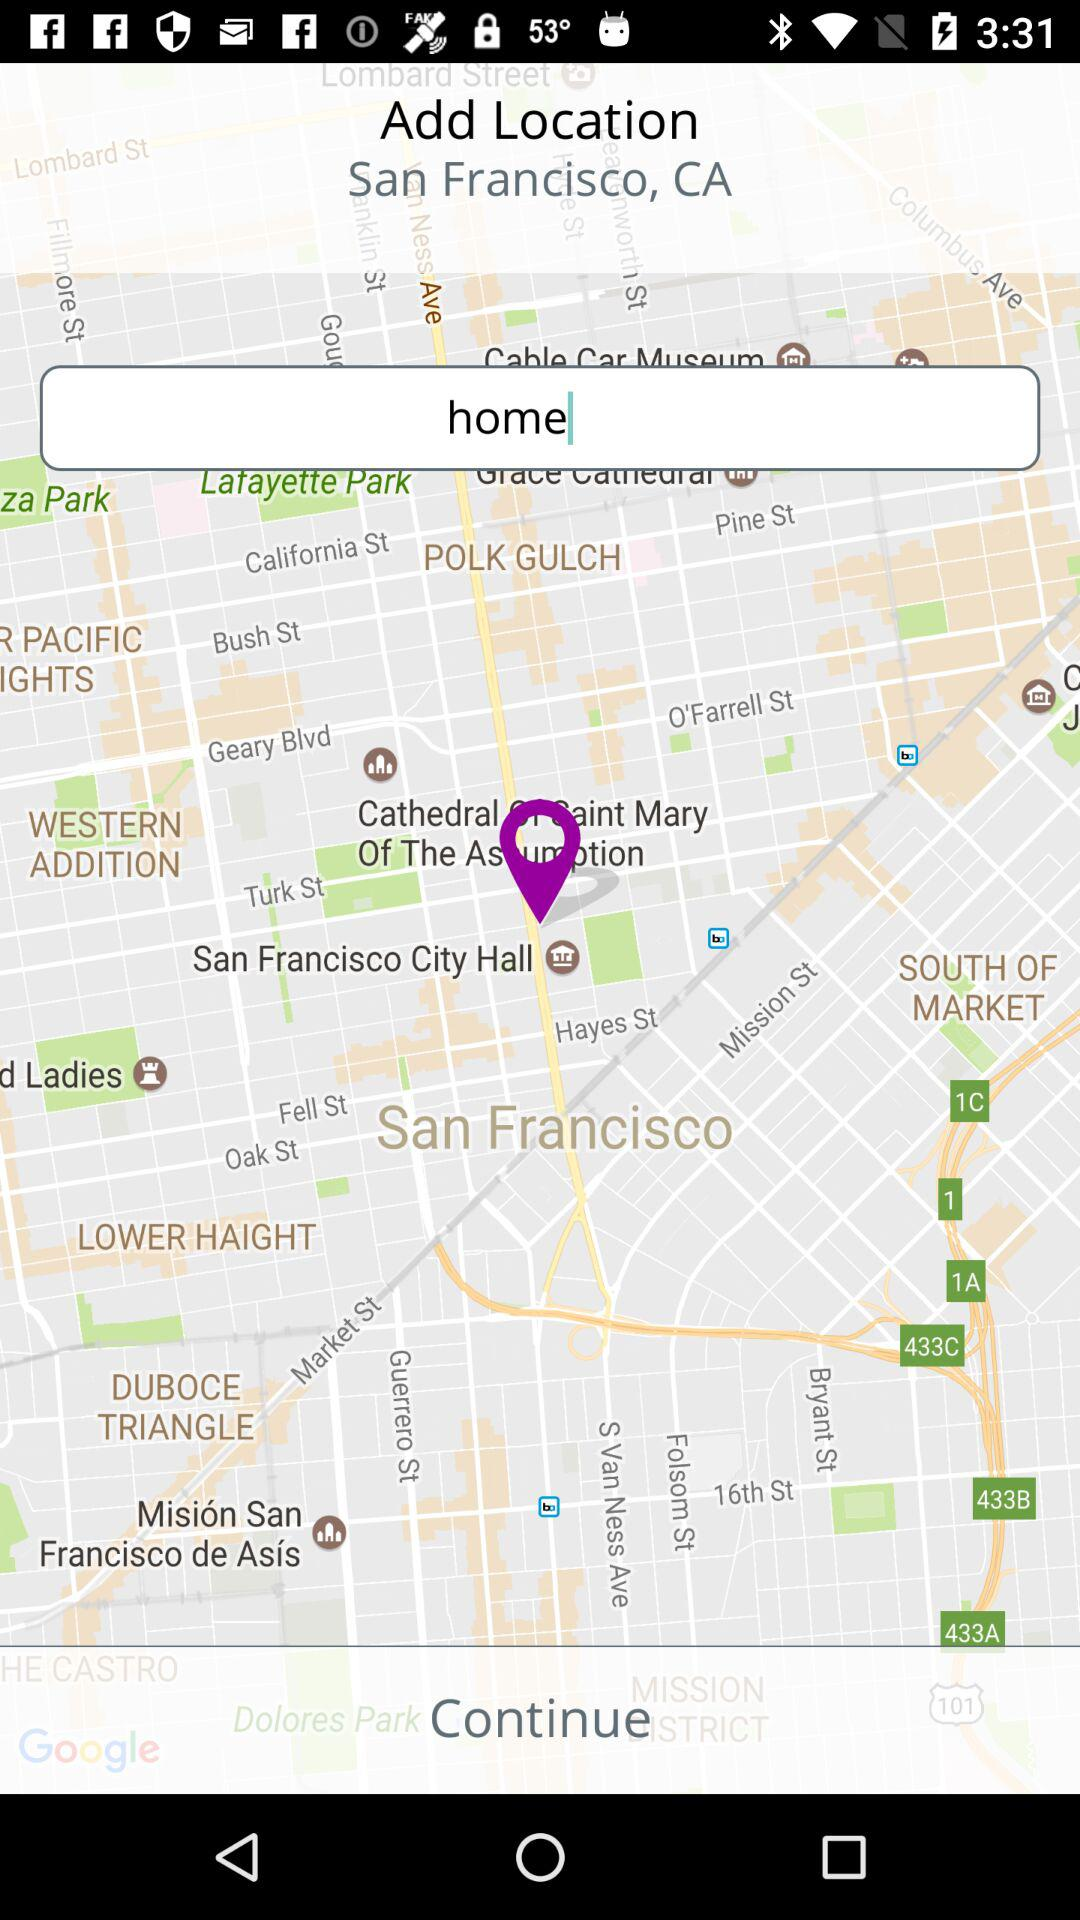What is the entered name for the location? The entered name for the location is "home". 